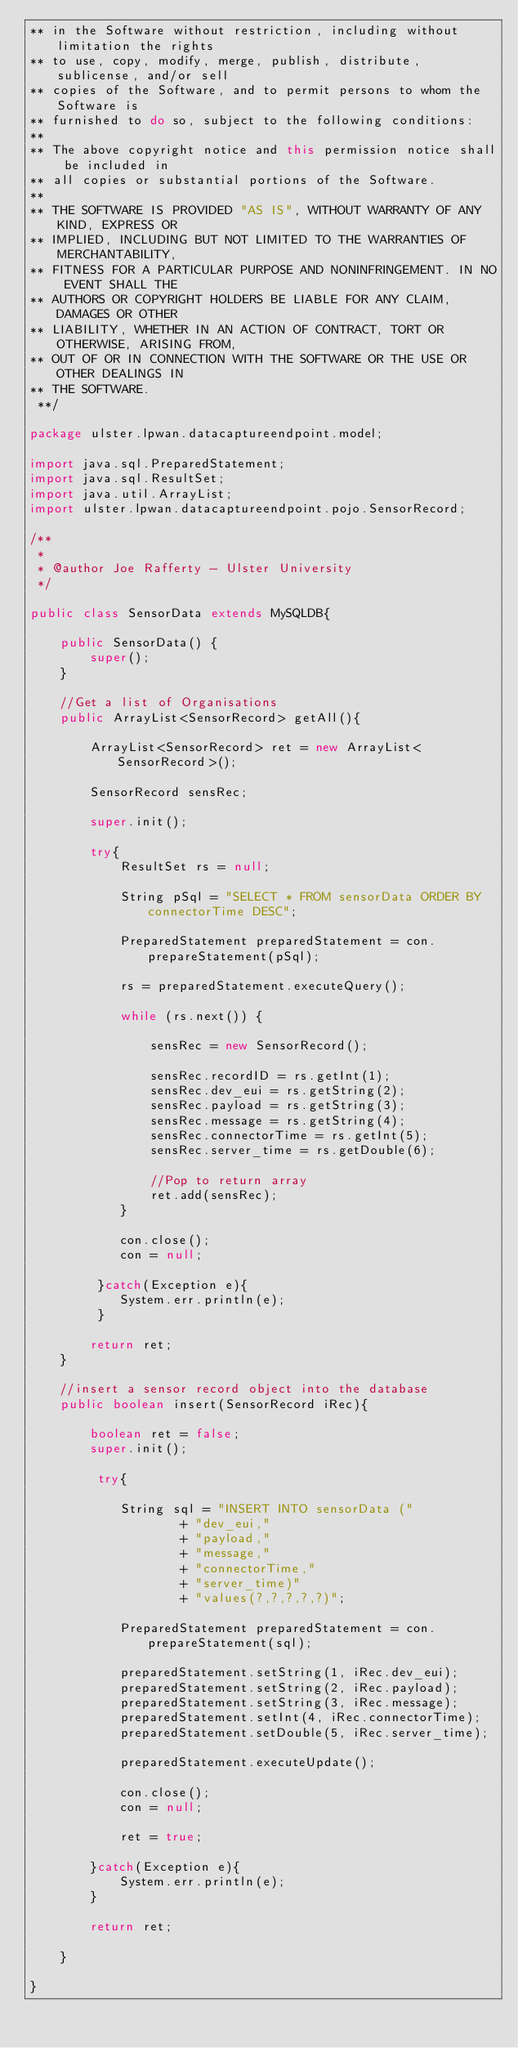Convert code to text. <code><loc_0><loc_0><loc_500><loc_500><_Java_>** in the Software without restriction, including without limitation the rights
** to use, copy, modify, merge, publish, distribute, sublicense, and/or sell
** copies of the Software, and to permit persons to whom the Software is
** furnished to do so, subject to the following conditions:
**
** The above copyright notice and this permission notice shall be included in
** all copies or substantial portions of the Software.
**
** THE SOFTWARE IS PROVIDED "AS IS", WITHOUT WARRANTY OF ANY KIND, EXPRESS OR
** IMPLIED, INCLUDING BUT NOT LIMITED TO THE WARRANTIES OF MERCHANTABILITY,
** FITNESS FOR A PARTICULAR PURPOSE AND NONINFRINGEMENT. IN NO EVENT SHALL THE
** AUTHORS OR COPYRIGHT HOLDERS BE LIABLE FOR ANY CLAIM, DAMAGES OR OTHER
** LIABILITY, WHETHER IN AN ACTION OF CONTRACT, TORT OR OTHERWISE, ARISING FROM,
** OUT OF OR IN CONNECTION WITH THE SOFTWARE OR THE USE OR OTHER DEALINGS IN
** THE SOFTWARE.
 **/

package ulster.lpwan.datacaptureendpoint.model;

import java.sql.PreparedStatement;
import java.sql.ResultSet;
import java.util.ArrayList;
import ulster.lpwan.datacaptureendpoint.pojo.SensorRecord;

/**
 *
 * @author Joe Rafferty - Ulster University
 */

public class SensorData extends MySQLDB{
 
    public SensorData() {
        super();
    }
    
    //Get a list of Organisations
    public ArrayList<SensorRecord> getAll(){
    
        ArrayList<SensorRecord> ret = new ArrayList<SensorRecord>();
        
        SensorRecord sensRec;
        
        super.init();
        
        try{
            ResultSet rs = null;
            
            String pSql = "SELECT * FROM sensorData ORDER BY connectorTime DESC";

            PreparedStatement preparedStatement = con.prepareStatement(pSql);
             
            rs = preparedStatement.executeQuery();
            
            while (rs.next()) {
                
                sensRec = new SensorRecord();
                
                sensRec.recordID = rs.getInt(1);
                sensRec.dev_eui = rs.getString(2);
                sensRec.payload = rs.getString(3);
                sensRec.message = rs.getString(4);
                sensRec.connectorTime = rs.getInt(5);
                sensRec.server_time = rs.getDouble(6);
                
                //Pop to return array
                ret.add(sensRec);
            }
            
            con.close();
            con = null;
   
         }catch(Exception e){
            System.err.println(e);
         }   
        
        return ret;
    }
    
    //insert a sensor record object into the database
    public boolean insert(SensorRecord iRec){
        
        boolean ret = false;
        super.init();
        
         try{
             
            String sql = "INSERT INTO sensorData ("
                    + "dev_eui,"
                    + "payload,"
                    + "message,"
                    + "connectorTime,"
                    + "server_time)"
                    + "values(?,?,?,?,?)";
            
            PreparedStatement preparedStatement = con.prepareStatement(sql);

            preparedStatement.setString(1, iRec.dev_eui);
            preparedStatement.setString(2, iRec.payload);
            preparedStatement.setString(3, iRec.message);
            preparedStatement.setInt(4, iRec.connectorTime);
            preparedStatement.setDouble(5, iRec.server_time);
            
            preparedStatement.executeUpdate();
            
            con.close();
            con = null;
              
            ret = true;
            
        }catch(Exception e){
            System.err.println(e);    
        }
        
        return ret;
        
    }
 
}</code> 